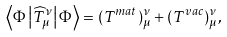Convert formula to latex. <formula><loc_0><loc_0><loc_500><loc_500>\left \langle \Phi \left | \widehat { T } _ { \mu } ^ { \nu } \right | \Phi \right \rangle = ( T ^ { m a t } ) _ { \mu } ^ { \nu } + ( T ^ { v a c } ) _ { \mu } ^ { \nu } ,</formula> 